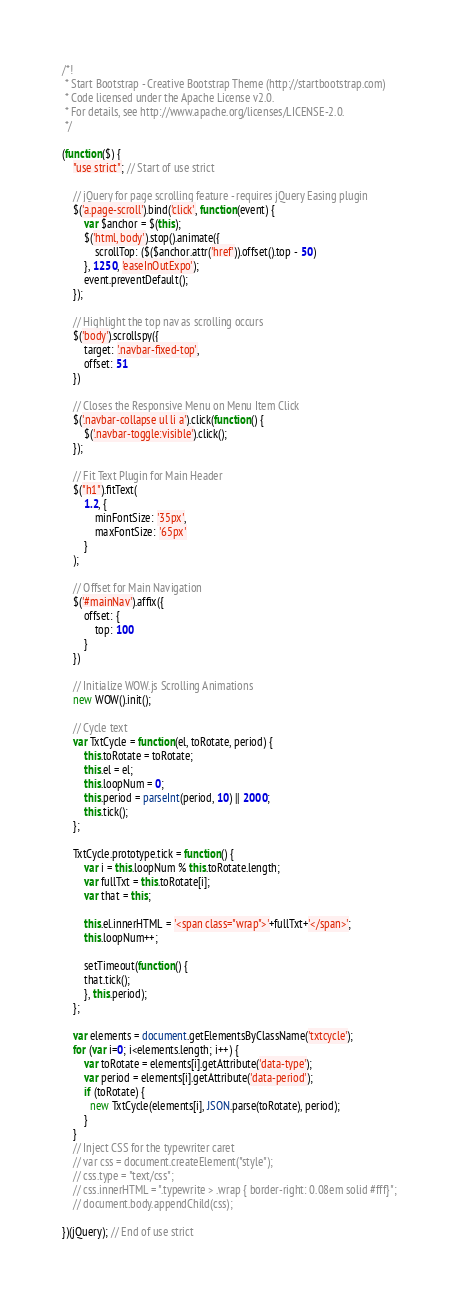<code> <loc_0><loc_0><loc_500><loc_500><_JavaScript_>/*!
 * Start Bootstrap - Creative Bootstrap Theme (http://startbootstrap.com)
 * Code licensed under the Apache License v2.0.
 * For details, see http://www.apache.org/licenses/LICENSE-2.0.
 */

(function($) {
    "use strict"; // Start of use strict

    // jQuery for page scrolling feature - requires jQuery Easing plugin
    $('a.page-scroll').bind('click', function(event) {
        var $anchor = $(this);
        $('html, body').stop().animate({
            scrollTop: ($($anchor.attr('href')).offset().top - 50)
        }, 1250, 'easeInOutExpo');
        event.preventDefault();
    });

    // Highlight the top nav as scrolling occurs
    $('body').scrollspy({
        target: '.navbar-fixed-top',
        offset: 51
    })

    // Closes the Responsive Menu on Menu Item Click
    $('.navbar-collapse ul li a').click(function() {
        $('.navbar-toggle:visible').click();
    });

    // Fit Text Plugin for Main Header
    $("h1").fitText(
        1.2, {
            minFontSize: '35px',
            maxFontSize: '65px'
        }
    );

    // Offset for Main Navigation
    $('#mainNav').affix({
        offset: {
            top: 100
        }
    })

    // Initialize WOW.js Scrolling Animations
    new WOW().init();

    // Cycle text
    var TxtCycle = function(el, toRotate, period) {
        this.toRotate = toRotate;
        this.el = el;
        this.loopNum = 0;
        this.period = parseInt(period, 10) || 2000;
        this.tick();
    };

    TxtCycle.prototype.tick = function() {
        var i = this.loopNum % this.toRotate.length;
        var fullTxt = this.toRotate[i];
        var that = this;

        this.el.innerHTML = '<span class="wrap">'+fullTxt+'</span>';
        this.loopNum++;

        setTimeout(function() {
        that.tick();
        }, this.period);
    };

    var elements = document.getElementsByClassName('txtcycle');
    for (var i=0; i<elements.length; i++) {
        var toRotate = elements[i].getAttribute('data-type');
        var period = elements[i].getAttribute('data-period');
        if (toRotate) {
          new TxtCycle(elements[i], JSON.parse(toRotate), period);
        }
    }
    // Inject CSS for the typewriter caret
    // var css = document.createElement("style");
    // css.type = "text/css";
    // css.innerHTML = ".typewrite > .wrap { border-right: 0.08em solid #fff}";
    // document.body.appendChild(css);

})(jQuery); // End of use strict
</code> 